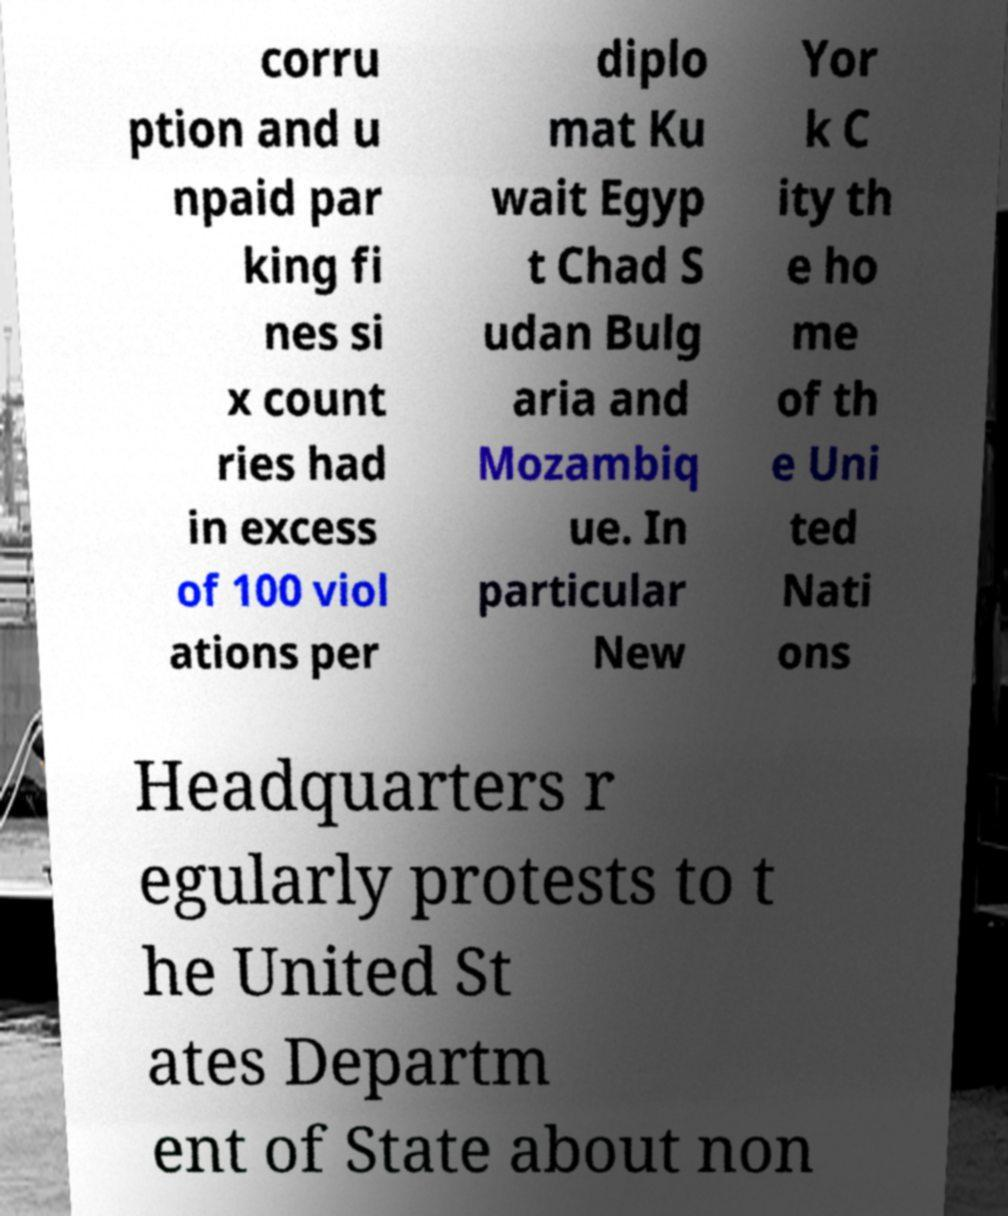Could you extract and type out the text from this image? corru ption and u npaid par king fi nes si x count ries had in excess of 100 viol ations per diplo mat Ku wait Egyp t Chad S udan Bulg aria and Mozambiq ue. In particular New Yor k C ity th e ho me of th e Uni ted Nati ons Headquarters r egularly protests to t he United St ates Departm ent of State about non 